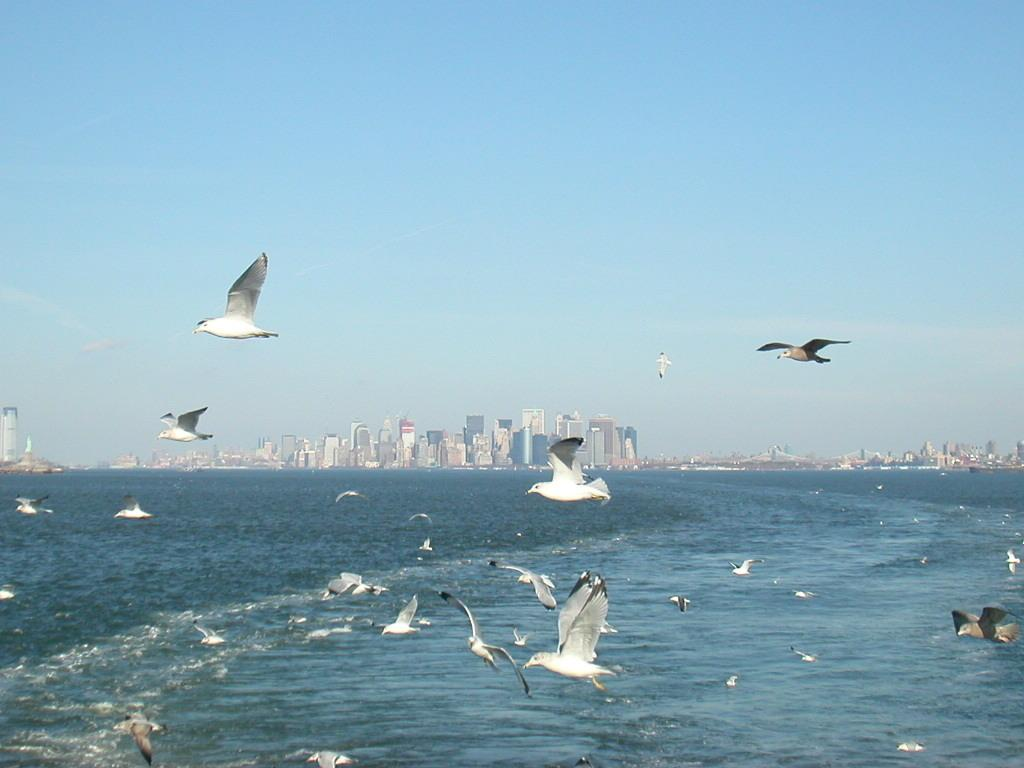What is happening in the sky in the image? There are birds flying in the sky in the image. What can be seen at the bottom of the picture? There is water visible at the bottom of the picture. What is visible in the background of the image? There are buildings in the background of the image. Where is the faucet located in the image? There is no faucet present in the image. What type of ink is being used by the birds in the image? There are no birds using ink in the image; they are simply flying in the sky. 